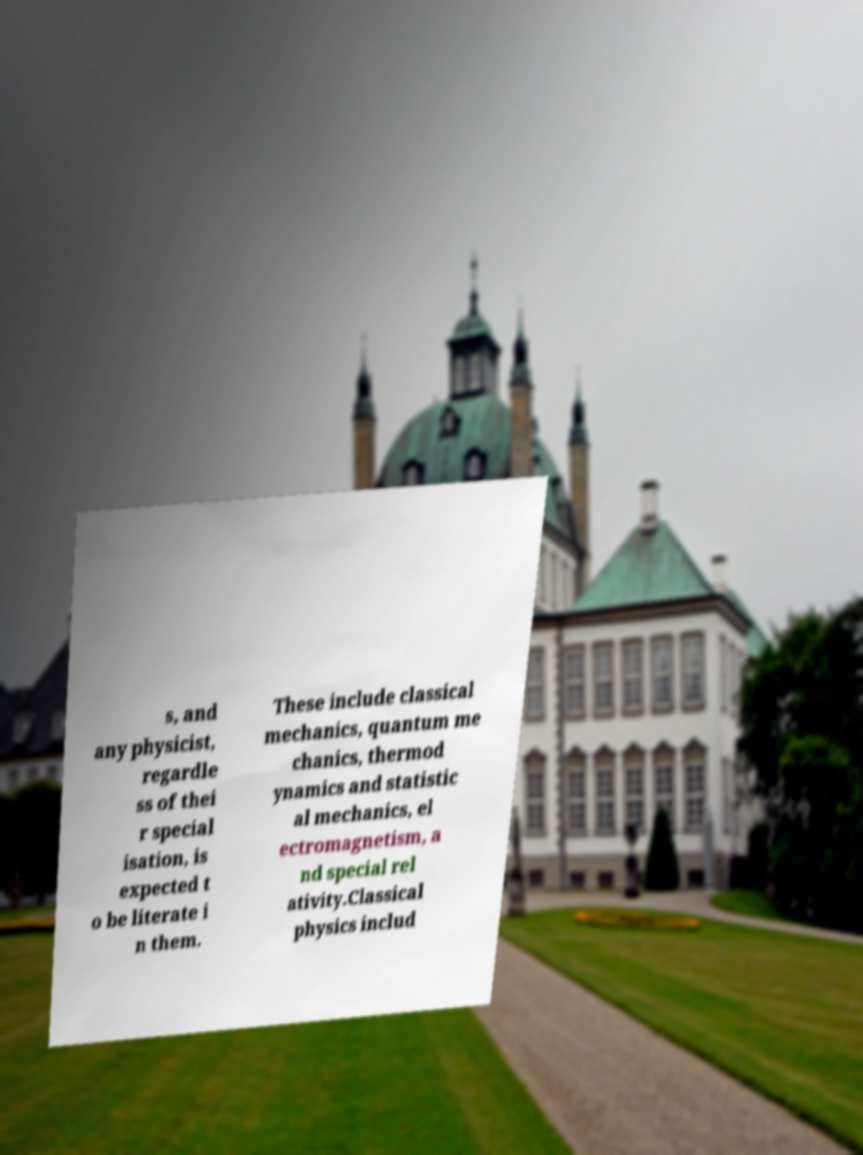Could you extract and type out the text from this image? s, and any physicist, regardle ss of thei r special isation, is expected t o be literate i n them. These include classical mechanics, quantum me chanics, thermod ynamics and statistic al mechanics, el ectromagnetism, a nd special rel ativity.Classical physics includ 